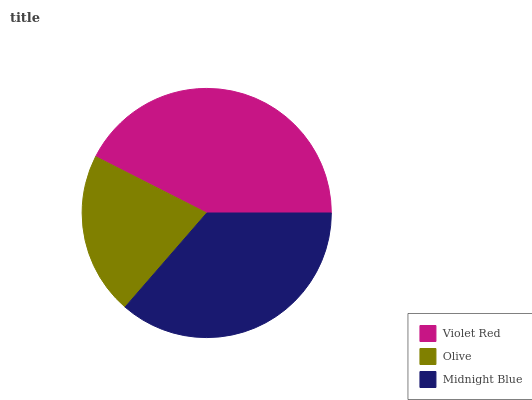Is Olive the minimum?
Answer yes or no. Yes. Is Violet Red the maximum?
Answer yes or no. Yes. Is Midnight Blue the minimum?
Answer yes or no. No. Is Midnight Blue the maximum?
Answer yes or no. No. Is Midnight Blue greater than Olive?
Answer yes or no. Yes. Is Olive less than Midnight Blue?
Answer yes or no. Yes. Is Olive greater than Midnight Blue?
Answer yes or no. No. Is Midnight Blue less than Olive?
Answer yes or no. No. Is Midnight Blue the high median?
Answer yes or no. Yes. Is Midnight Blue the low median?
Answer yes or no. Yes. Is Olive the high median?
Answer yes or no. No. Is Violet Red the low median?
Answer yes or no. No. 